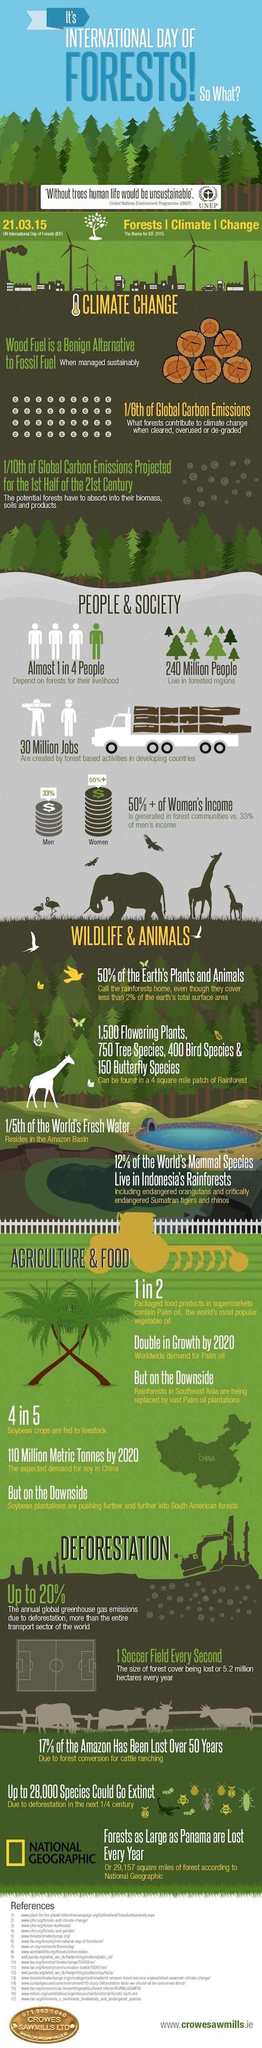When was the International day of forests celebrated in 2015?
Answer the question with a short phrase. 21.03.15 How many people live in the forested regions? 240 Million What percentage of men's incomes is generated in forest communities? 33% What percentage of the world's mammal species live in Indonesia's rainforests? 12% 